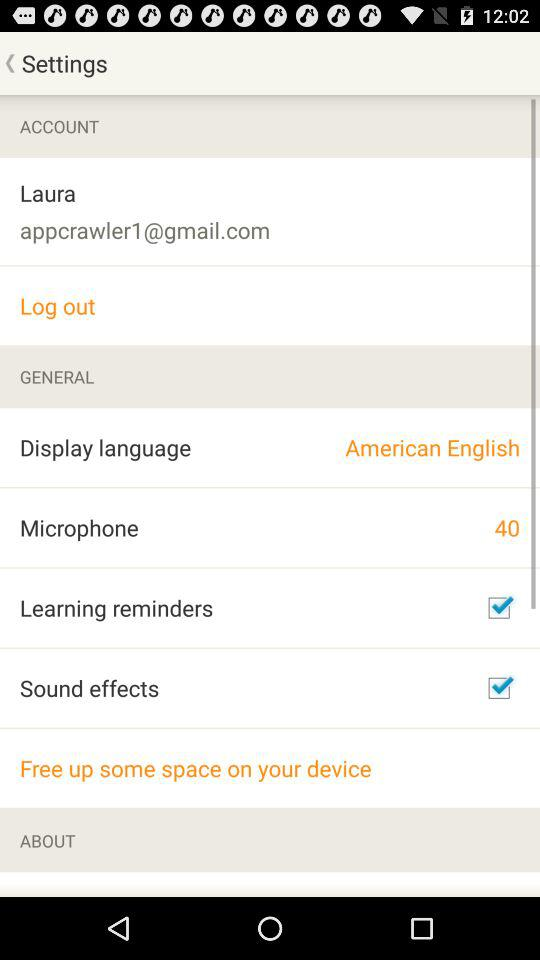What is the status of "Sound effects"? The status is "on". 